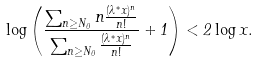<formula> <loc_0><loc_0><loc_500><loc_500>\log \left ( \frac { \sum _ { n \geq N _ { 0 } } n \frac { ( \lambda ^ { * } x ) ^ { n } } { n ! } } { \sum _ { n \geq N _ { 0 } } \frac { ( \lambda ^ { * } x ) ^ { n } } { n ! } } + 1 \right ) < 2 \log x .</formula> 